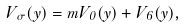Convert formula to latex. <formula><loc_0><loc_0><loc_500><loc_500>V _ { \sigma } ( y ) = m V _ { 0 } ( y ) + V _ { 6 } ( y ) ,</formula> 